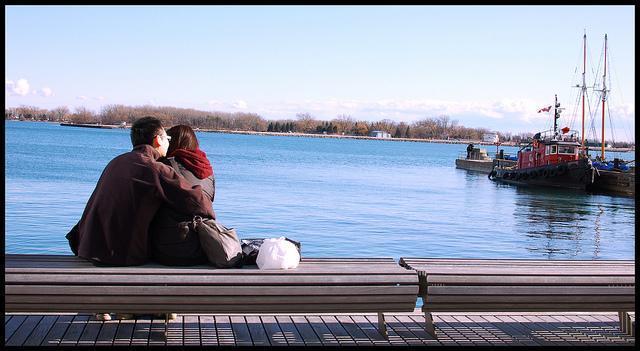How many people are in the photo?
Give a very brief answer. 2. How many benches are there?
Give a very brief answer. 2. 